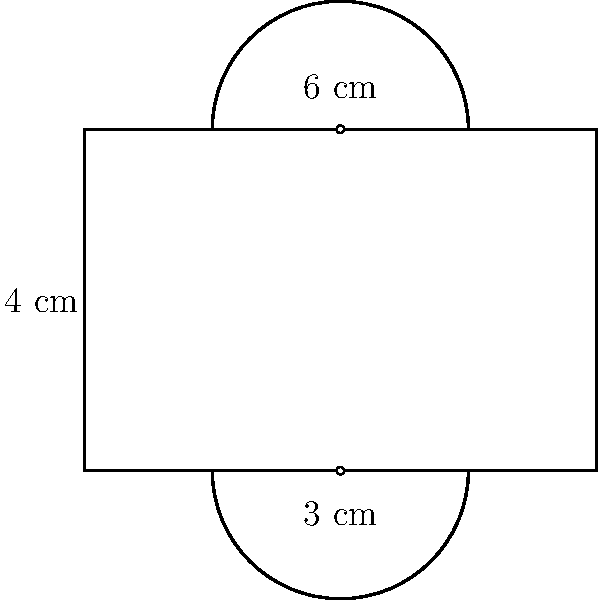A stage backdrop for a musical production is designed with a rectangular center and two semicircular ends, as shown in the figure. If the width of the rectangle is 6 cm and its height is 4 cm, what is the total area of the backdrop in square centimeters? (Use $\pi = 3.14$) To find the total area, we need to calculate the areas of the rectangle and the two semicircles separately, then add them together.

1. Area of the rectangle:
   $A_{rectangle} = width \times height = 6 \text{ cm} \times 4 \text{ cm} = 24 \text{ cm}^2$

2. Area of one semicircle:
   The radius of each semicircle is half the height of the rectangle: $r = 4 \text{ cm} \div 2 = 2 \text{ cm}$
   $A_{semicircle} = \frac{1}{2} \times \pi r^2 = \frac{1}{2} \times 3.14 \times 2^2 = 6.28 \text{ cm}^2$

3. Total area of two semicircles:
   $A_{two semicircles} = 2 \times 6.28 \text{ cm}^2 = 12.56 \text{ cm}^2$

4. Total area of the backdrop:
   $A_{total} = A_{rectangle} + A_{two semicircles} = 24 \text{ cm}^2 + 12.56 \text{ cm}^2 = 36.56 \text{ cm}^2$

Therefore, the total area of the backdrop is 36.56 square centimeters.
Answer: $36.56 \text{ cm}^2$ 